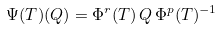Convert formula to latex. <formula><loc_0><loc_0><loc_500><loc_500>\Psi ( T ) ( Q ) = \Phi ^ { r } ( T ) \, Q \, \Phi ^ { p } ( T ) ^ { - 1 }</formula> 